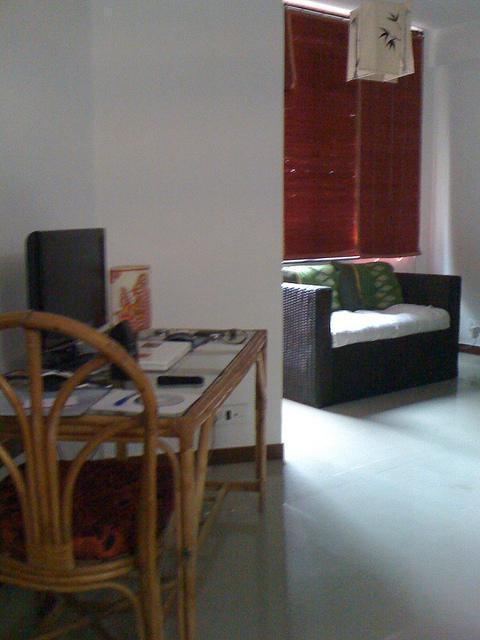How many zebras are pictured?
Give a very brief answer. 0. 